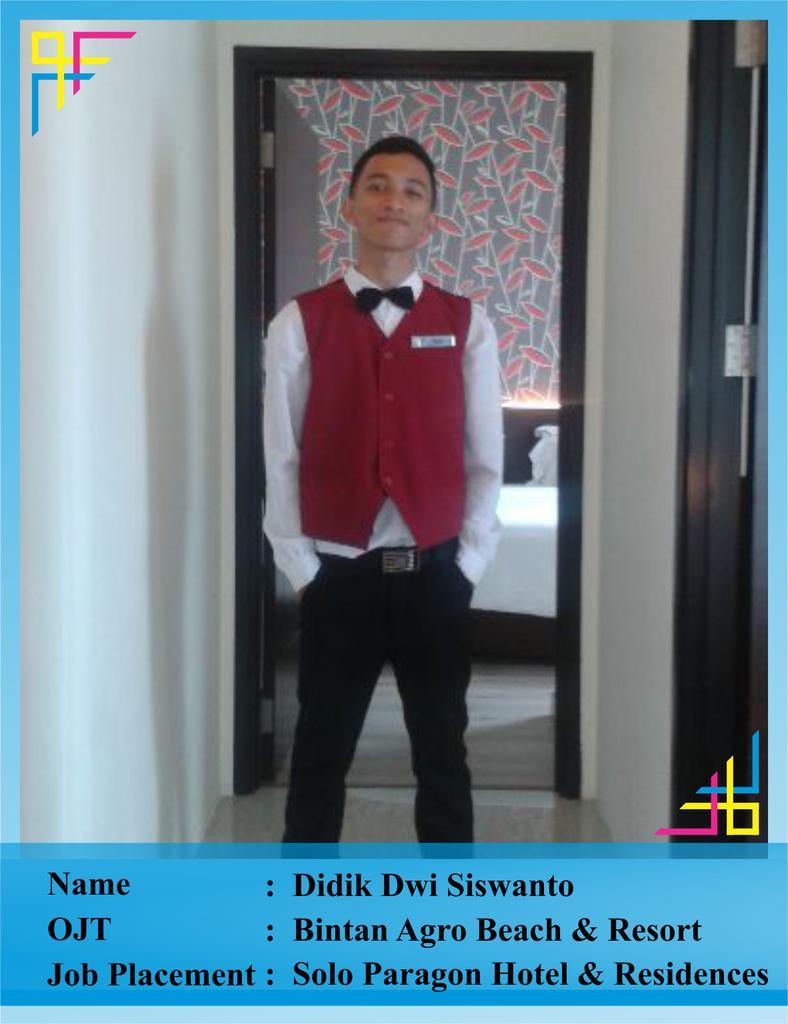In one or two sentences, can you explain what this image depicts? I can see this is an edited image. There is a person standing, there are walls, there is door and there are some other objects. Also there are words on the image. 